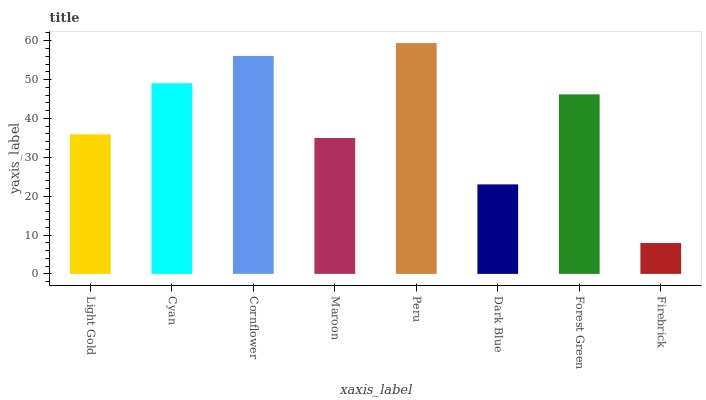Is Firebrick the minimum?
Answer yes or no. Yes. Is Peru the maximum?
Answer yes or no. Yes. Is Cyan the minimum?
Answer yes or no. No. Is Cyan the maximum?
Answer yes or no. No. Is Cyan greater than Light Gold?
Answer yes or no. Yes. Is Light Gold less than Cyan?
Answer yes or no. Yes. Is Light Gold greater than Cyan?
Answer yes or no. No. Is Cyan less than Light Gold?
Answer yes or no. No. Is Forest Green the high median?
Answer yes or no. Yes. Is Light Gold the low median?
Answer yes or no. Yes. Is Maroon the high median?
Answer yes or no. No. Is Maroon the low median?
Answer yes or no. No. 